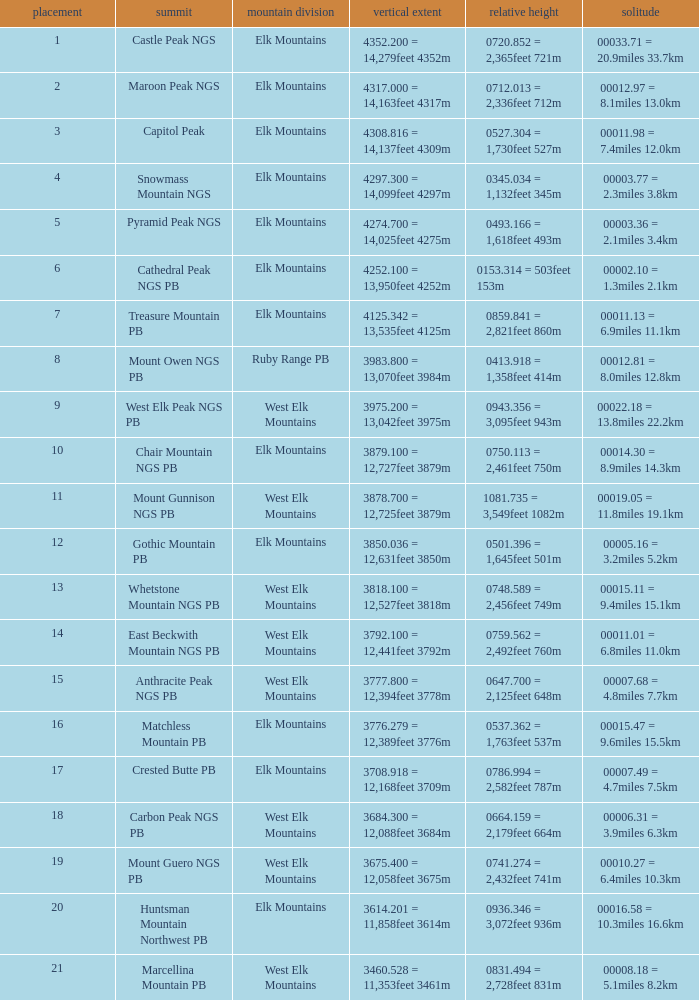Name the Prominence of the Mountain Peak of matchless mountain pb? 0537.362 = 1,763feet 537m. 